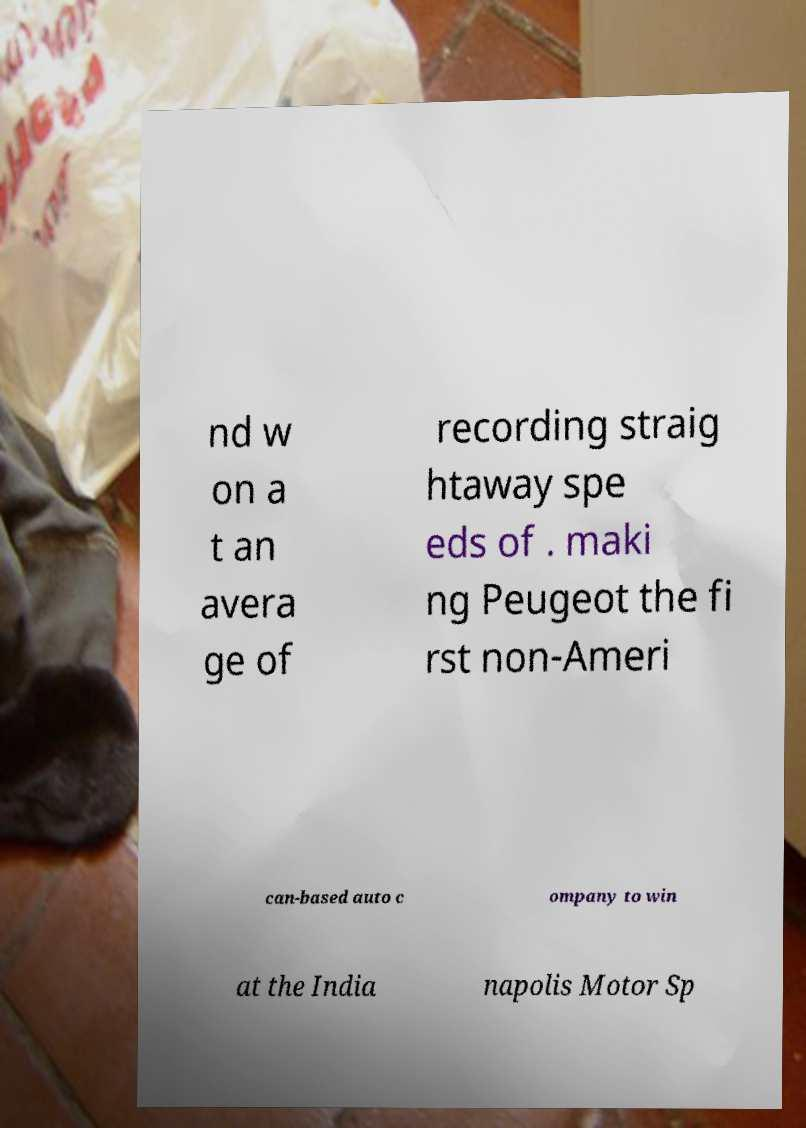I need the written content from this picture converted into text. Can you do that? nd w on a t an avera ge of recording straig htaway spe eds of . maki ng Peugeot the fi rst non-Ameri can-based auto c ompany to win at the India napolis Motor Sp 